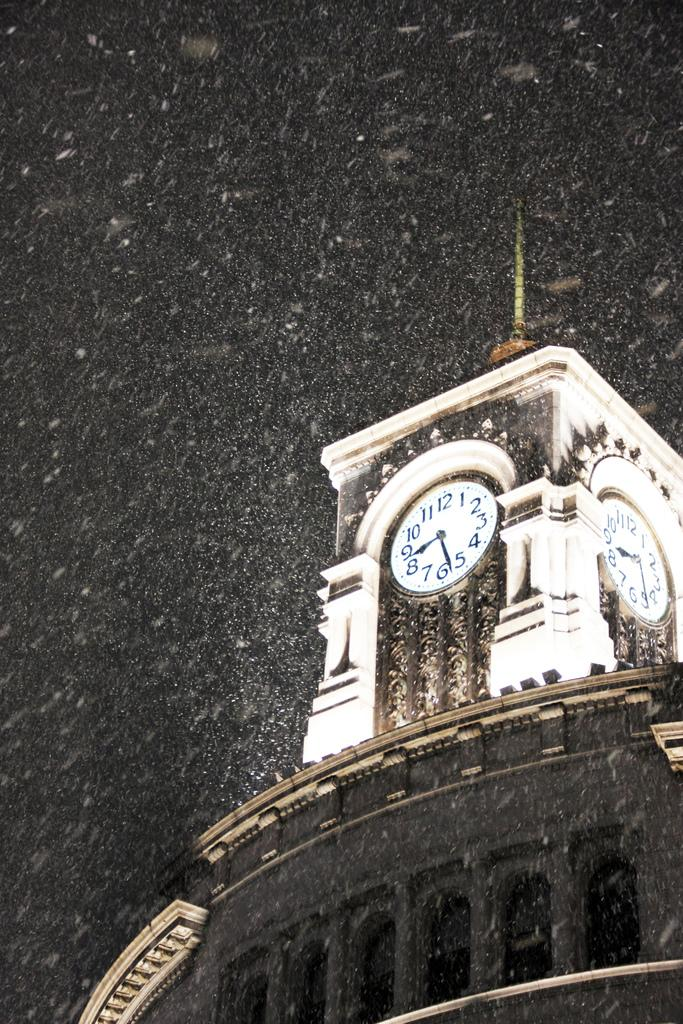What type of building is in the image? There is a clock tower building in the image. What is happening to the building in the image? Snow is falling on the building in the image. How would you describe the sky in the image? The sky is dark in the image. How many jellyfish can be seen swimming in the sky in the image? There are no jellyfish present in the image, and they cannot swim in the sky. 